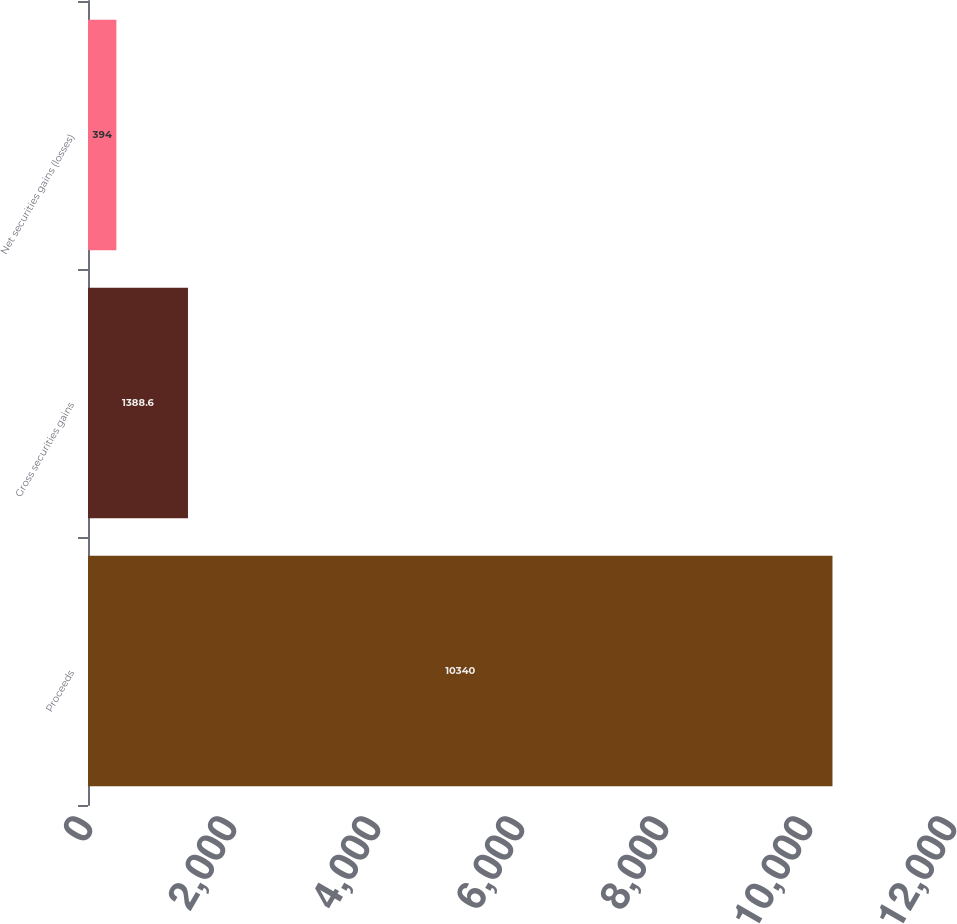Convert chart. <chart><loc_0><loc_0><loc_500><loc_500><bar_chart><fcel>Proceeds<fcel>Gross securities gains<fcel>Net securities gains (losses)<nl><fcel>10340<fcel>1388.6<fcel>394<nl></chart> 